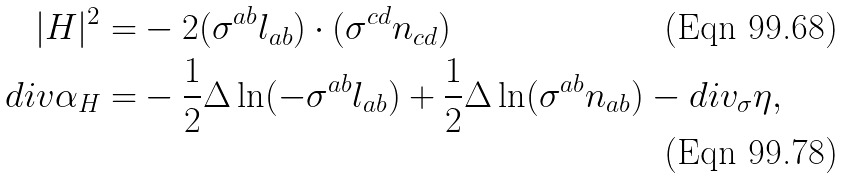Convert formula to latex. <formula><loc_0><loc_0><loc_500><loc_500>| H | ^ { 2 } = & - 2 ( \sigma ^ { a b } l _ { a b } ) \cdot ( \sigma ^ { c d } n _ { c d } ) \\ d i v \alpha _ { H } = & - \frac { 1 } { 2 } \Delta \ln ( - \sigma ^ { a b } l _ { a b } ) + \frac { 1 } { 2 } \Delta \ln ( \sigma ^ { a b } n _ { a b } ) - d i v _ { \sigma } \eta ,</formula> 